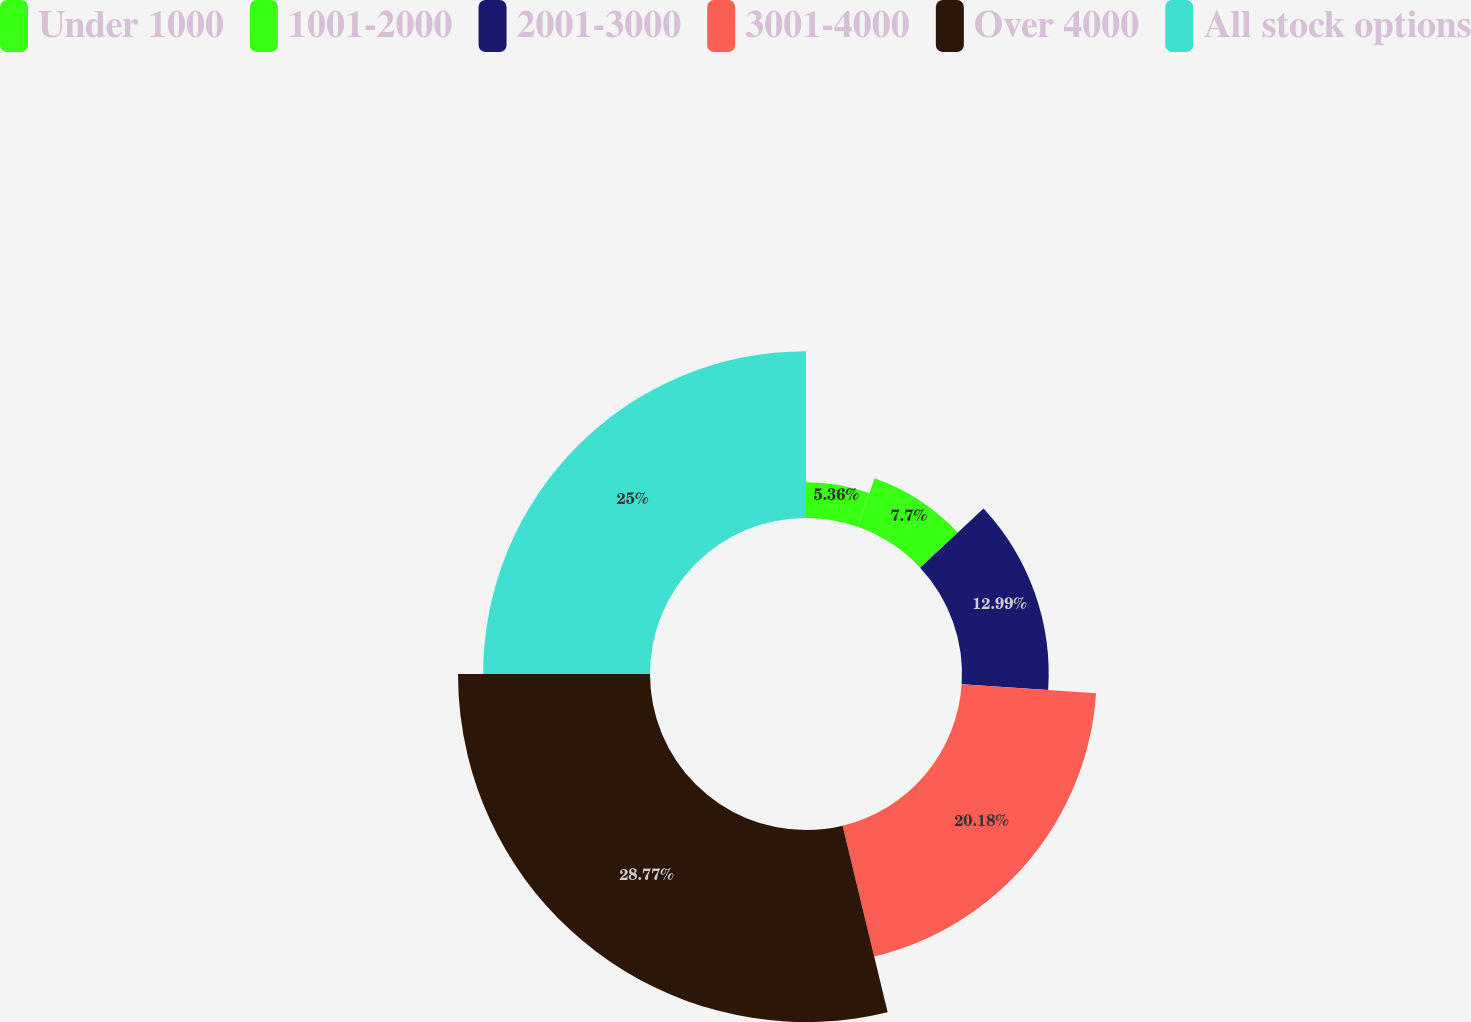<chart> <loc_0><loc_0><loc_500><loc_500><pie_chart><fcel>Under 1000<fcel>1001-2000<fcel>2001-3000<fcel>3001-4000<fcel>Over 4000<fcel>All stock options<nl><fcel>5.36%<fcel>7.7%<fcel>12.99%<fcel>20.18%<fcel>28.77%<fcel>25.0%<nl></chart> 